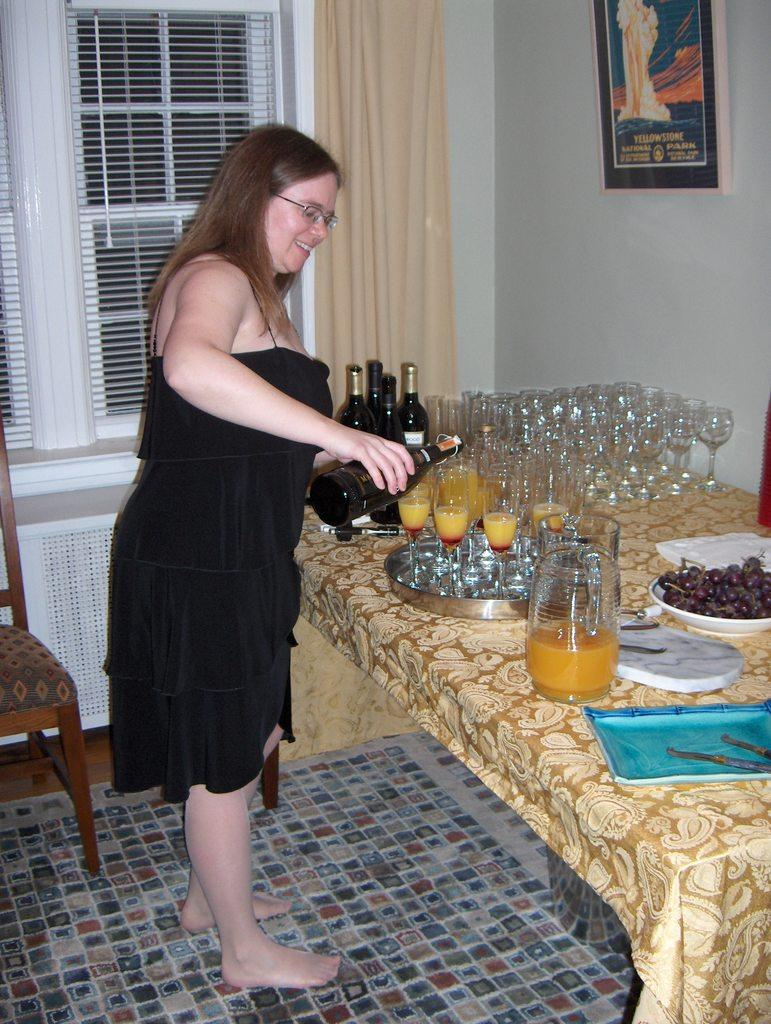What is the woman wearing in the image? The woman is wearing a black dress in the image. What is the woman doing in the image? The woman is standing in the image. What is the woman holding in her hand? The woman is holding a drink bottle in her hand. What can be seen on the table in the image? There are many glasses and some bottles on the table in the image. What type of transport is visible in the image? There is no transport visible in the image. Can you tell me when the woman gave birth in the image? There is no information about the woman giving birth in the image. 